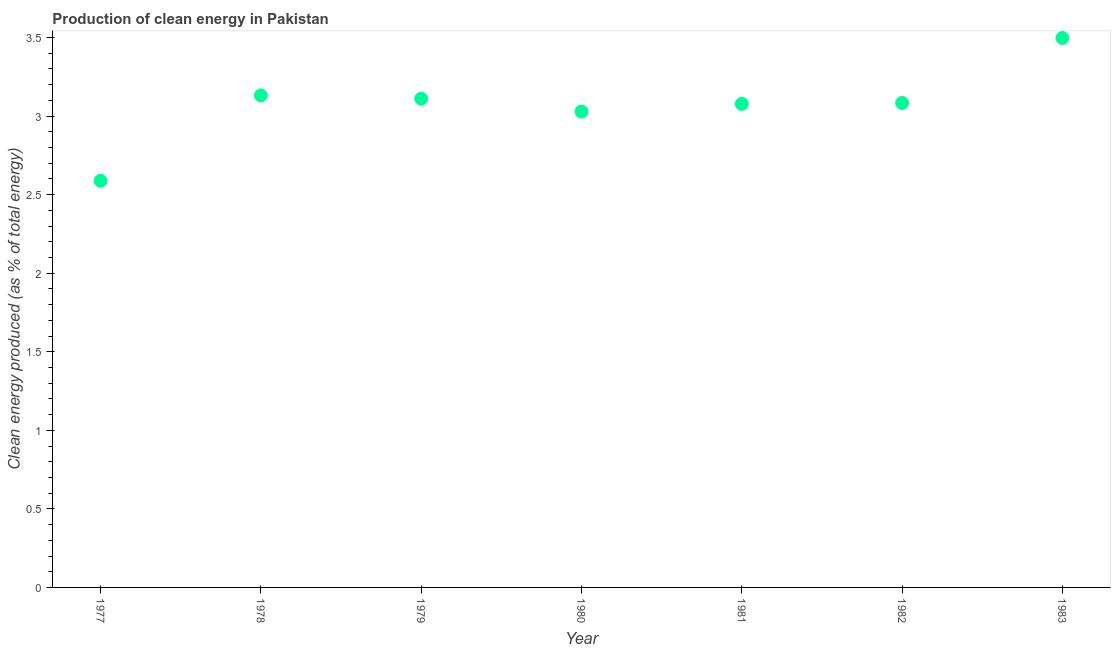What is the production of clean energy in 1979?
Your response must be concise. 3.11. Across all years, what is the maximum production of clean energy?
Make the answer very short. 3.5. Across all years, what is the minimum production of clean energy?
Give a very brief answer. 2.59. In which year was the production of clean energy maximum?
Make the answer very short. 1983. In which year was the production of clean energy minimum?
Keep it short and to the point. 1977. What is the sum of the production of clean energy?
Your answer should be compact. 21.52. What is the difference between the production of clean energy in 1977 and 1983?
Your response must be concise. -0.91. What is the average production of clean energy per year?
Your response must be concise. 3.07. What is the median production of clean energy?
Offer a terse response. 3.08. In how many years, is the production of clean energy greater than 1.1 %?
Give a very brief answer. 7. Do a majority of the years between 1977 and 1981 (inclusive) have production of clean energy greater than 2.4 %?
Provide a short and direct response. Yes. What is the ratio of the production of clean energy in 1978 to that in 1981?
Keep it short and to the point. 1.02. What is the difference between the highest and the second highest production of clean energy?
Offer a very short reply. 0.37. Is the sum of the production of clean energy in 1977 and 1978 greater than the maximum production of clean energy across all years?
Ensure brevity in your answer.  Yes. What is the difference between the highest and the lowest production of clean energy?
Your answer should be compact. 0.91. In how many years, is the production of clean energy greater than the average production of clean energy taken over all years?
Offer a very short reply. 5. How many years are there in the graph?
Offer a very short reply. 7. What is the difference between two consecutive major ticks on the Y-axis?
Keep it short and to the point. 0.5. Does the graph contain grids?
Offer a terse response. No. What is the title of the graph?
Give a very brief answer. Production of clean energy in Pakistan. What is the label or title of the Y-axis?
Provide a short and direct response. Clean energy produced (as % of total energy). What is the Clean energy produced (as % of total energy) in 1977?
Your answer should be compact. 2.59. What is the Clean energy produced (as % of total energy) in 1978?
Offer a terse response. 3.13. What is the Clean energy produced (as % of total energy) in 1979?
Provide a short and direct response. 3.11. What is the Clean energy produced (as % of total energy) in 1980?
Your response must be concise. 3.03. What is the Clean energy produced (as % of total energy) in 1981?
Provide a succinct answer. 3.08. What is the Clean energy produced (as % of total energy) in 1982?
Keep it short and to the point. 3.08. What is the Clean energy produced (as % of total energy) in 1983?
Ensure brevity in your answer.  3.5. What is the difference between the Clean energy produced (as % of total energy) in 1977 and 1978?
Give a very brief answer. -0.54. What is the difference between the Clean energy produced (as % of total energy) in 1977 and 1979?
Provide a succinct answer. -0.52. What is the difference between the Clean energy produced (as % of total energy) in 1977 and 1980?
Give a very brief answer. -0.44. What is the difference between the Clean energy produced (as % of total energy) in 1977 and 1981?
Offer a very short reply. -0.49. What is the difference between the Clean energy produced (as % of total energy) in 1977 and 1982?
Ensure brevity in your answer.  -0.5. What is the difference between the Clean energy produced (as % of total energy) in 1977 and 1983?
Offer a terse response. -0.91. What is the difference between the Clean energy produced (as % of total energy) in 1978 and 1979?
Offer a very short reply. 0.02. What is the difference between the Clean energy produced (as % of total energy) in 1978 and 1980?
Your answer should be very brief. 0.1. What is the difference between the Clean energy produced (as % of total energy) in 1978 and 1981?
Keep it short and to the point. 0.05. What is the difference between the Clean energy produced (as % of total energy) in 1978 and 1982?
Your answer should be very brief. 0.05. What is the difference between the Clean energy produced (as % of total energy) in 1978 and 1983?
Keep it short and to the point. -0.37. What is the difference between the Clean energy produced (as % of total energy) in 1979 and 1980?
Offer a very short reply. 0.08. What is the difference between the Clean energy produced (as % of total energy) in 1979 and 1981?
Ensure brevity in your answer.  0.03. What is the difference between the Clean energy produced (as % of total energy) in 1979 and 1982?
Offer a terse response. 0.03. What is the difference between the Clean energy produced (as % of total energy) in 1979 and 1983?
Offer a terse response. -0.39. What is the difference between the Clean energy produced (as % of total energy) in 1980 and 1981?
Your response must be concise. -0.05. What is the difference between the Clean energy produced (as % of total energy) in 1980 and 1982?
Ensure brevity in your answer.  -0.06. What is the difference between the Clean energy produced (as % of total energy) in 1980 and 1983?
Make the answer very short. -0.47. What is the difference between the Clean energy produced (as % of total energy) in 1981 and 1982?
Offer a very short reply. -0.01. What is the difference between the Clean energy produced (as % of total energy) in 1981 and 1983?
Keep it short and to the point. -0.42. What is the difference between the Clean energy produced (as % of total energy) in 1982 and 1983?
Your answer should be very brief. -0.41. What is the ratio of the Clean energy produced (as % of total energy) in 1977 to that in 1978?
Your response must be concise. 0.83. What is the ratio of the Clean energy produced (as % of total energy) in 1977 to that in 1979?
Give a very brief answer. 0.83. What is the ratio of the Clean energy produced (as % of total energy) in 1977 to that in 1980?
Provide a succinct answer. 0.85. What is the ratio of the Clean energy produced (as % of total energy) in 1977 to that in 1981?
Give a very brief answer. 0.84. What is the ratio of the Clean energy produced (as % of total energy) in 1977 to that in 1982?
Your answer should be compact. 0.84. What is the ratio of the Clean energy produced (as % of total energy) in 1977 to that in 1983?
Provide a succinct answer. 0.74. What is the ratio of the Clean energy produced (as % of total energy) in 1978 to that in 1979?
Provide a succinct answer. 1.01. What is the ratio of the Clean energy produced (as % of total energy) in 1978 to that in 1980?
Provide a short and direct response. 1.03. What is the ratio of the Clean energy produced (as % of total energy) in 1978 to that in 1982?
Offer a very short reply. 1.02. What is the ratio of the Clean energy produced (as % of total energy) in 1978 to that in 1983?
Offer a terse response. 0.9. What is the ratio of the Clean energy produced (as % of total energy) in 1979 to that in 1981?
Offer a very short reply. 1.01. What is the ratio of the Clean energy produced (as % of total energy) in 1979 to that in 1982?
Ensure brevity in your answer.  1.01. What is the ratio of the Clean energy produced (as % of total energy) in 1979 to that in 1983?
Your answer should be very brief. 0.89. What is the ratio of the Clean energy produced (as % of total energy) in 1980 to that in 1982?
Your answer should be very brief. 0.98. What is the ratio of the Clean energy produced (as % of total energy) in 1980 to that in 1983?
Offer a very short reply. 0.87. What is the ratio of the Clean energy produced (as % of total energy) in 1982 to that in 1983?
Provide a succinct answer. 0.88. 